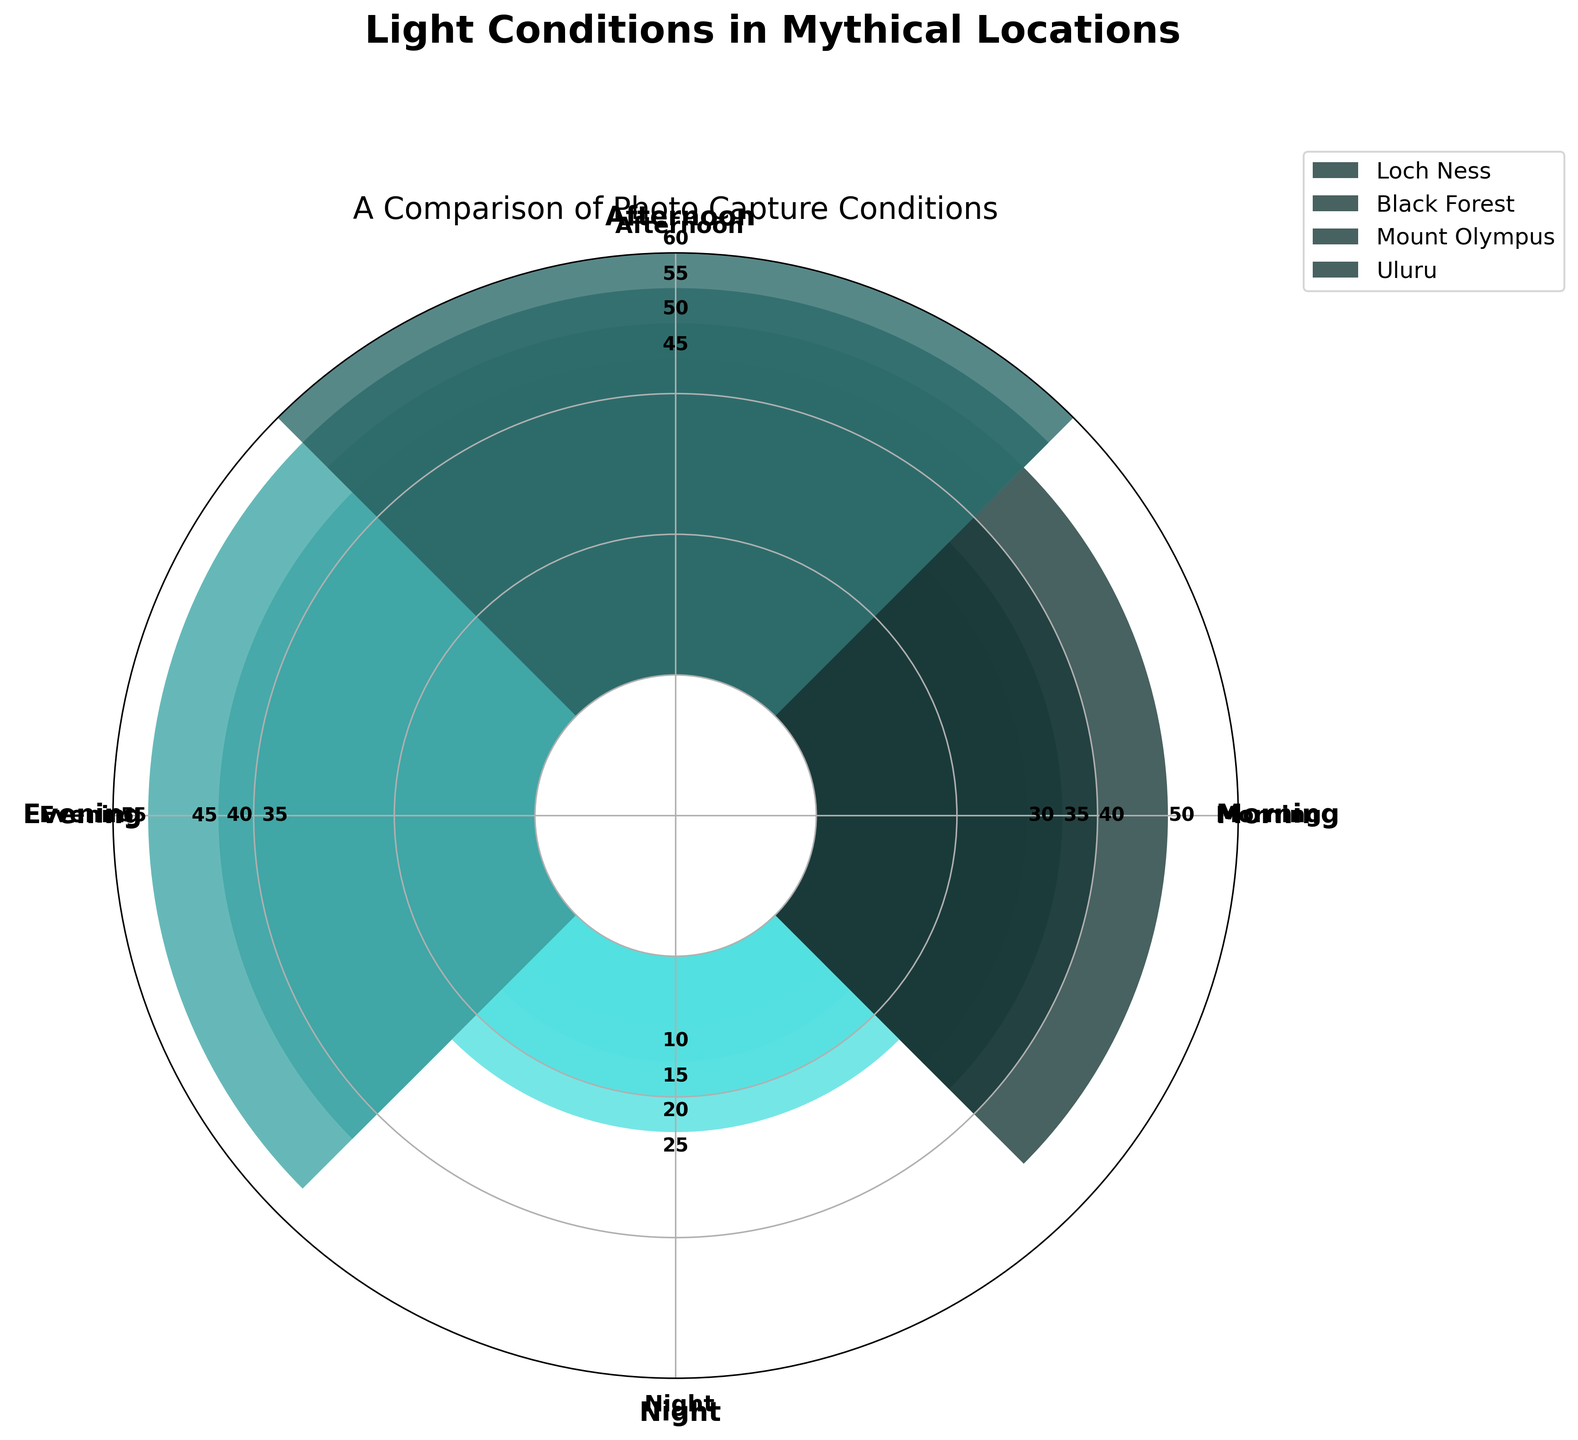Which location shows the highest light condition in the afternoon? To answer this question, identify the light conditions for all locations in the afternoon and compare them. Mount Olympus has 55, Loch Ness has 50, Black Forest has 45, and Uluru has 60. Therefore, Uluru has the highest light condition in the afternoon.
Answer: Uluru What's the lowest light condition recorded at night across all locations? Check the light conditions at night for all the locations: Loch Ness (15), Black Forest (20), Mount Olympus (10), Uluru (25). The lowest value among these is 10 for Mount Olympus.
Answer: Mount Olympus How many locations have a morning light condition higher than their evening light condition? Compare morning and evening light conditions for each location: 
- Loch Ness: Morning (35) vs Evening (40)
- Black Forest: Morning (30) vs Evening (55)
- Mount Olympus: Morning (40) vs Evening (35)
- Uluru: Morning (50) vs Evening (45)
Mount Olympus and Uluru have higher morning light conditions compared to their evening conditions.
Answer: 2 What is the average light condition in the evening across all locations? Sum the light conditions in the evening for all locations and then divide by the number of locations. The values are Loch Ness (40), Black Forest (55), Mount Olympus (35), Uluru (45). The total is 40+55+35+45 = 175. There are 4 locations, so the average is 175/4 = 43.75.
Answer: 43.75 Which location has the most balanced light condition throughout the day? Examine the range of light conditions for each location. The smaller the range, the more balanced it is:
- Loch Ness: 35 (Morning) to 15 (Night) – Range 50 - 15 = 35
- Black Forest: 30 (Morning) to 20 (Night) – Range 55 - 20 = 35
- Mount Olympus: 40 (Morning) to 10 (Night) – Range 55 - 10 = 45
- Uluru: 50 (Morning) to 25 (Night) – Range 60 - 25 = 35
All ranges seem identical (35), so none has a particularly more balanced condition than others.
Answer: Loch Ness, Black Forest, Uluru Between Loch Ness and Black Forest, whose light conditions peak at the evening time? Compare the evening light conditions for Loch Ness (40) and Black Forest (55). Black Forest has a higher peak in the evening.
Answer: Black Forest What is the difference in afternoon light conditions between Mount Olympus and Uluru? Subtract the afternoon light condition of Mount Olympus (55) from that of Uluru (60). The difference is 60 - 55 = 5.
Answer: 5 Which location has the most variable light conditions throughout the day? Considering that ‘variable’ implies the largest range from the maximum to the minimum:
- Loch Ness: Range 50 - 15 = 35
- Black Forest: Range 55 - 20 = 35
- Mount Olympus: Range 55 - 10 = 45
- Uluru: Range 60 - 25 = 35
Mount Olympus has the widest range of light conditions throughout the day.
Answer: Mount Olympus 